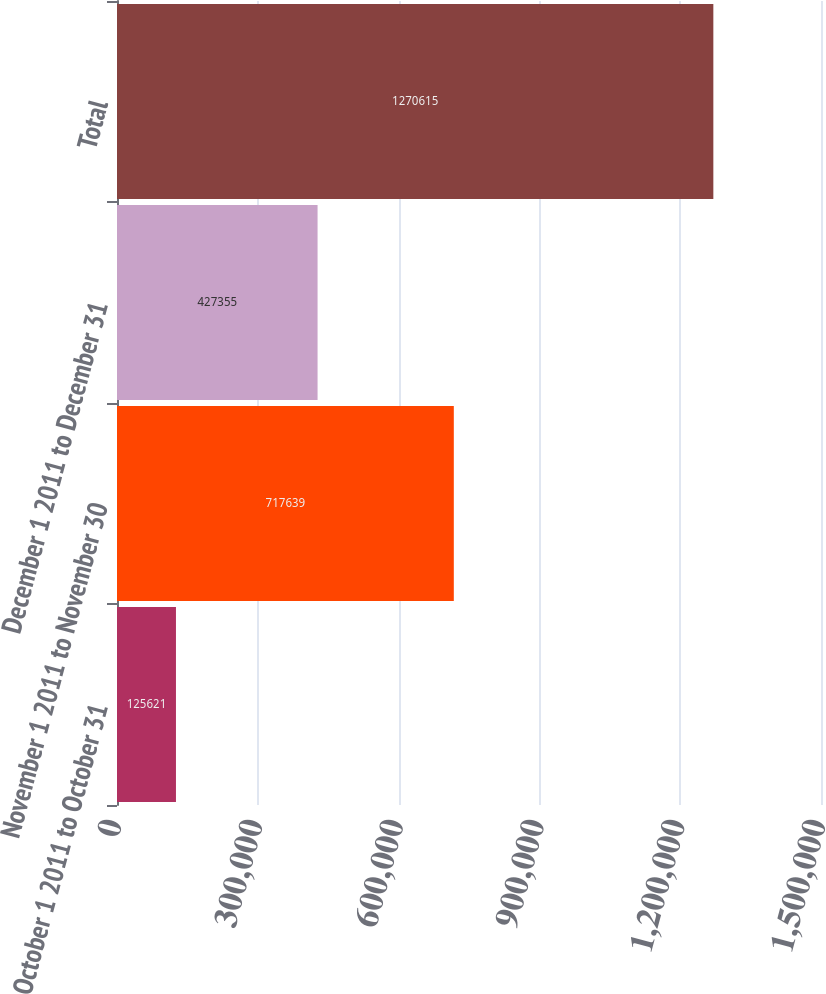Convert chart to OTSL. <chart><loc_0><loc_0><loc_500><loc_500><bar_chart><fcel>October 1 2011 to October 31<fcel>November 1 2011 to November 30<fcel>December 1 2011 to December 31<fcel>Total<nl><fcel>125621<fcel>717639<fcel>427355<fcel>1.27062e+06<nl></chart> 